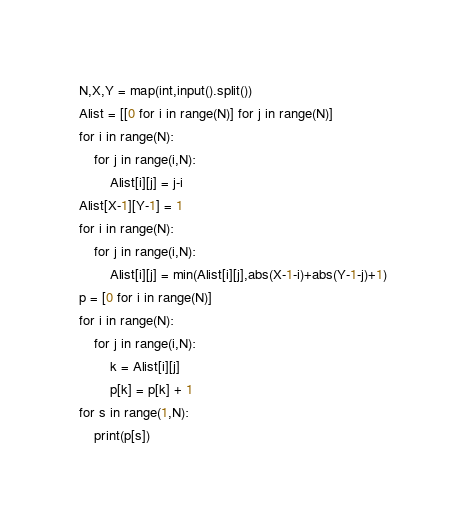Convert code to text. <code><loc_0><loc_0><loc_500><loc_500><_Python_>N,X,Y = map(int,input().split())
Alist = [[0 for i in range(N)] for j in range(N)]
for i in range(N):
    for j in range(i,N):
        Alist[i][j] = j-i
Alist[X-1][Y-1] = 1
for i in range(N):
    for j in range(i,N):
        Alist[i][j] = min(Alist[i][j],abs(X-1-i)+abs(Y-1-j)+1)
p = [0 for i in range(N)]
for i in range(N):
    for j in range(i,N):
        k = Alist[i][j]
        p[k] = p[k] + 1
for s in range(1,N):
    print(p[s])</code> 